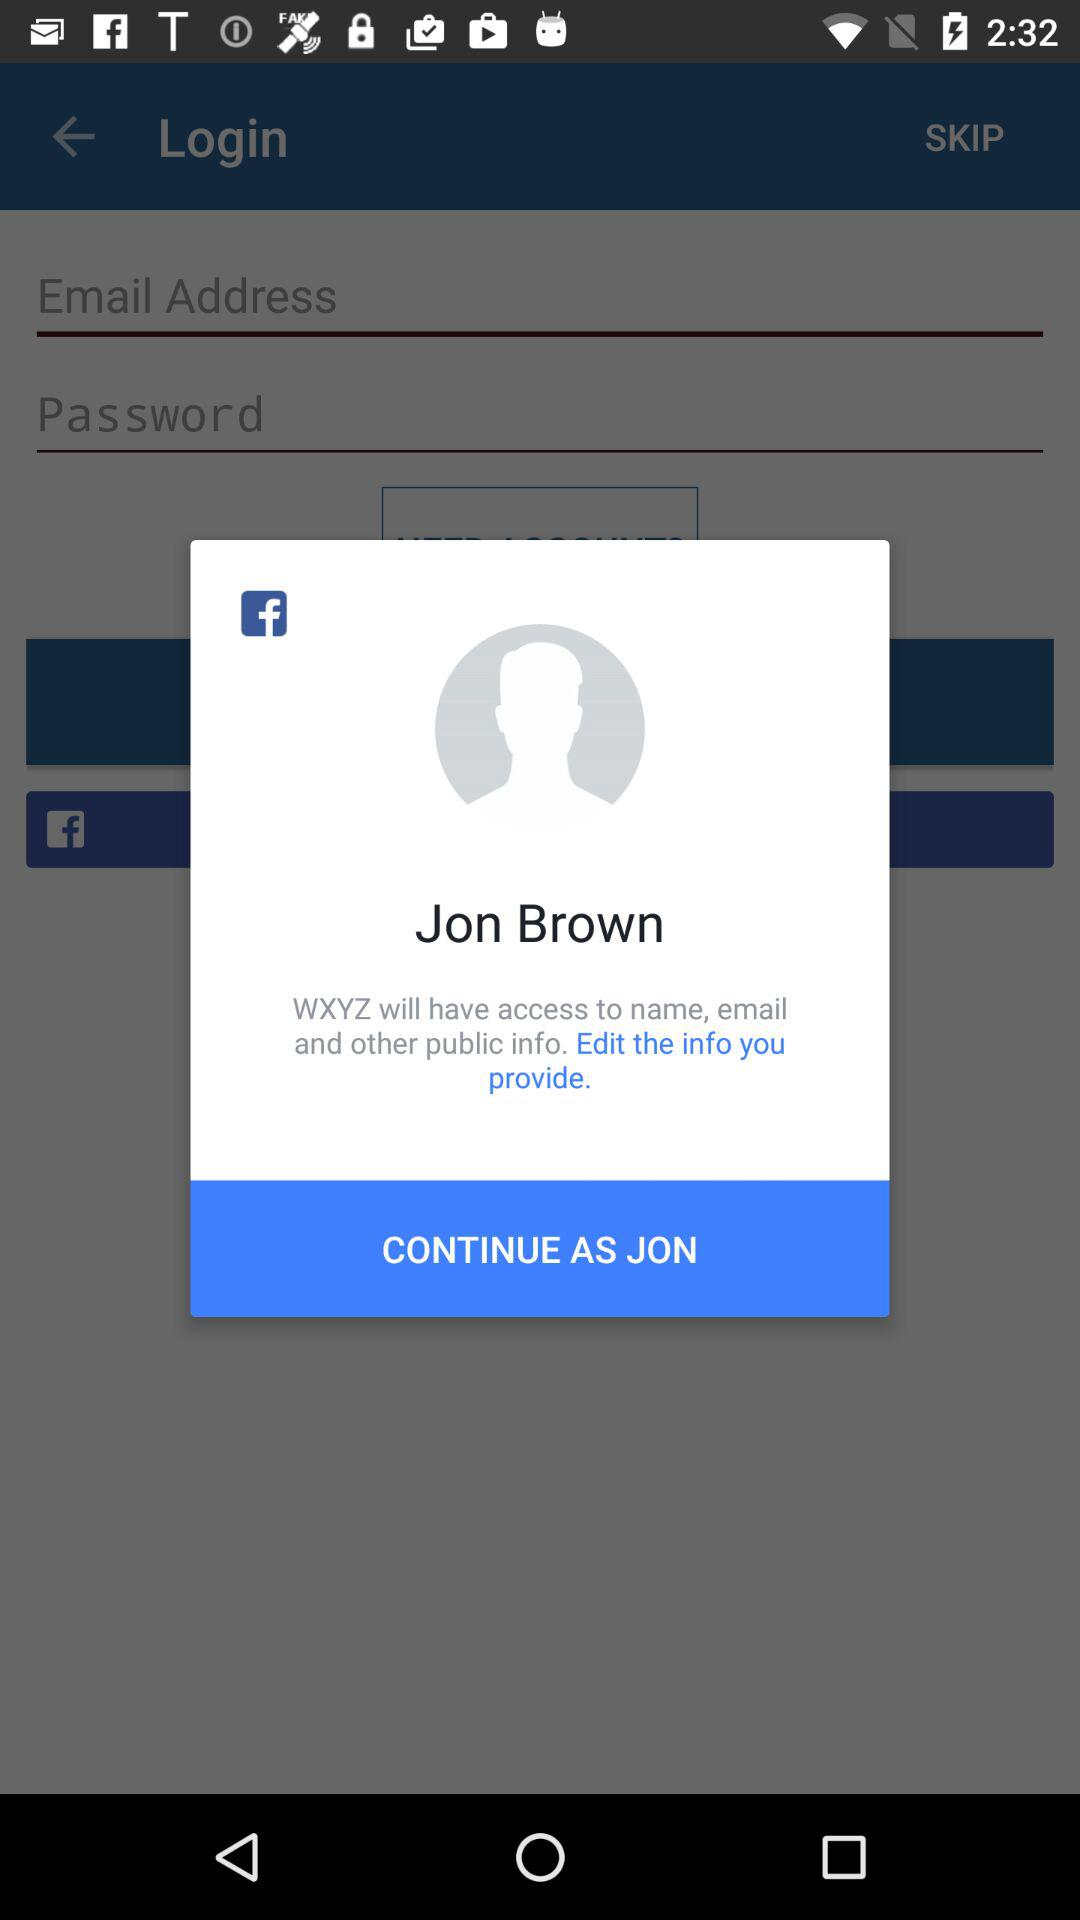What is the user name? The user name is Jon Brown. 